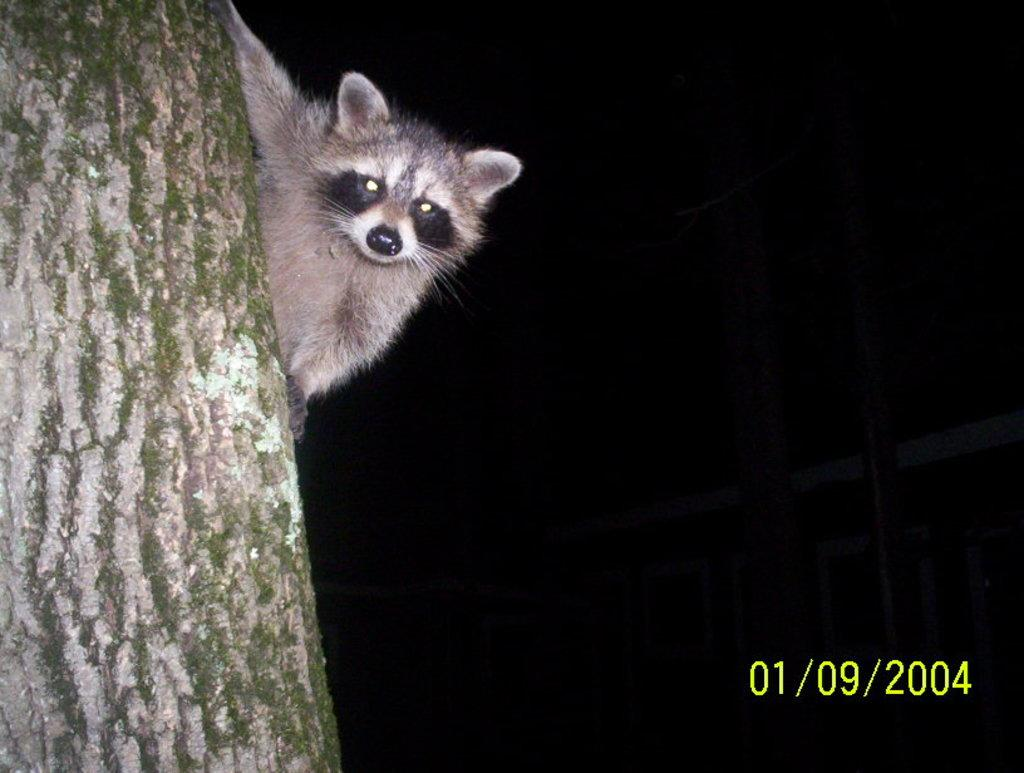What is the main subject of the image? There is an animal on a tree in the image. Where is the animal located in the image? The animal is on the left side of the image. What else can be seen in the image besides the animal? There is some text on the right side of the image. What type of seed is the animal holding in its mouth in the image? There is no seed present in the image, nor is the animal holding anything in its mouth. 